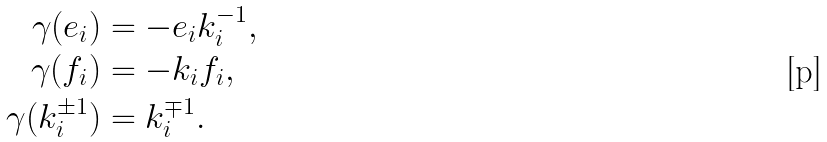<formula> <loc_0><loc_0><loc_500><loc_500>\gamma ( e _ { i } ) & = - e _ { i } k _ { i } ^ { - 1 } , \\ \gamma ( f _ { i } ) & = - k _ { i } f _ { i } , \\ \gamma ( k _ { i } ^ { \pm 1 } ) & = k _ { i } ^ { \mp 1 } .</formula> 